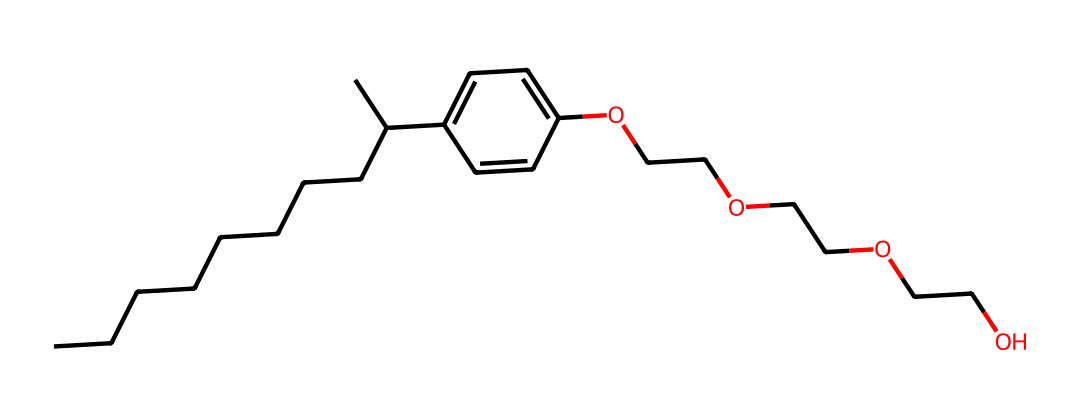What is the main functional group in this chemical? The structure contains a hydroxyl group (-OH) connected to a benzene ring, which is characteristic of phenols.
Answer: hydroxyl How many carbon atoms are in the chemical structure? By analyzing the SMILES, one can count the carbon atoms: there are 15 carbon atoms represented in the chain and ring structures combined.
Answer: 15 What type of surfactant is represented by this chemical? Nonylphenol ethoxylates are a type of nonionic surfactant, deriving from the nonylphenol backbone and being used often in various formulations.
Answer: nonionic surfactant What kind of aromatic ring is present in this chemical? The chemical features a phenolic aromatic ring, which is characterized by having six carbon atoms in a cyclic structure with alternating double bonds.
Answer: phenolic How many ethylene oxide units are present in this molecule? The ethoxylate portion of the structure, indicated by the repeated -OCC- units, totals to three ethylene oxide units contributing to its surfactant properties.
Answer: 3 